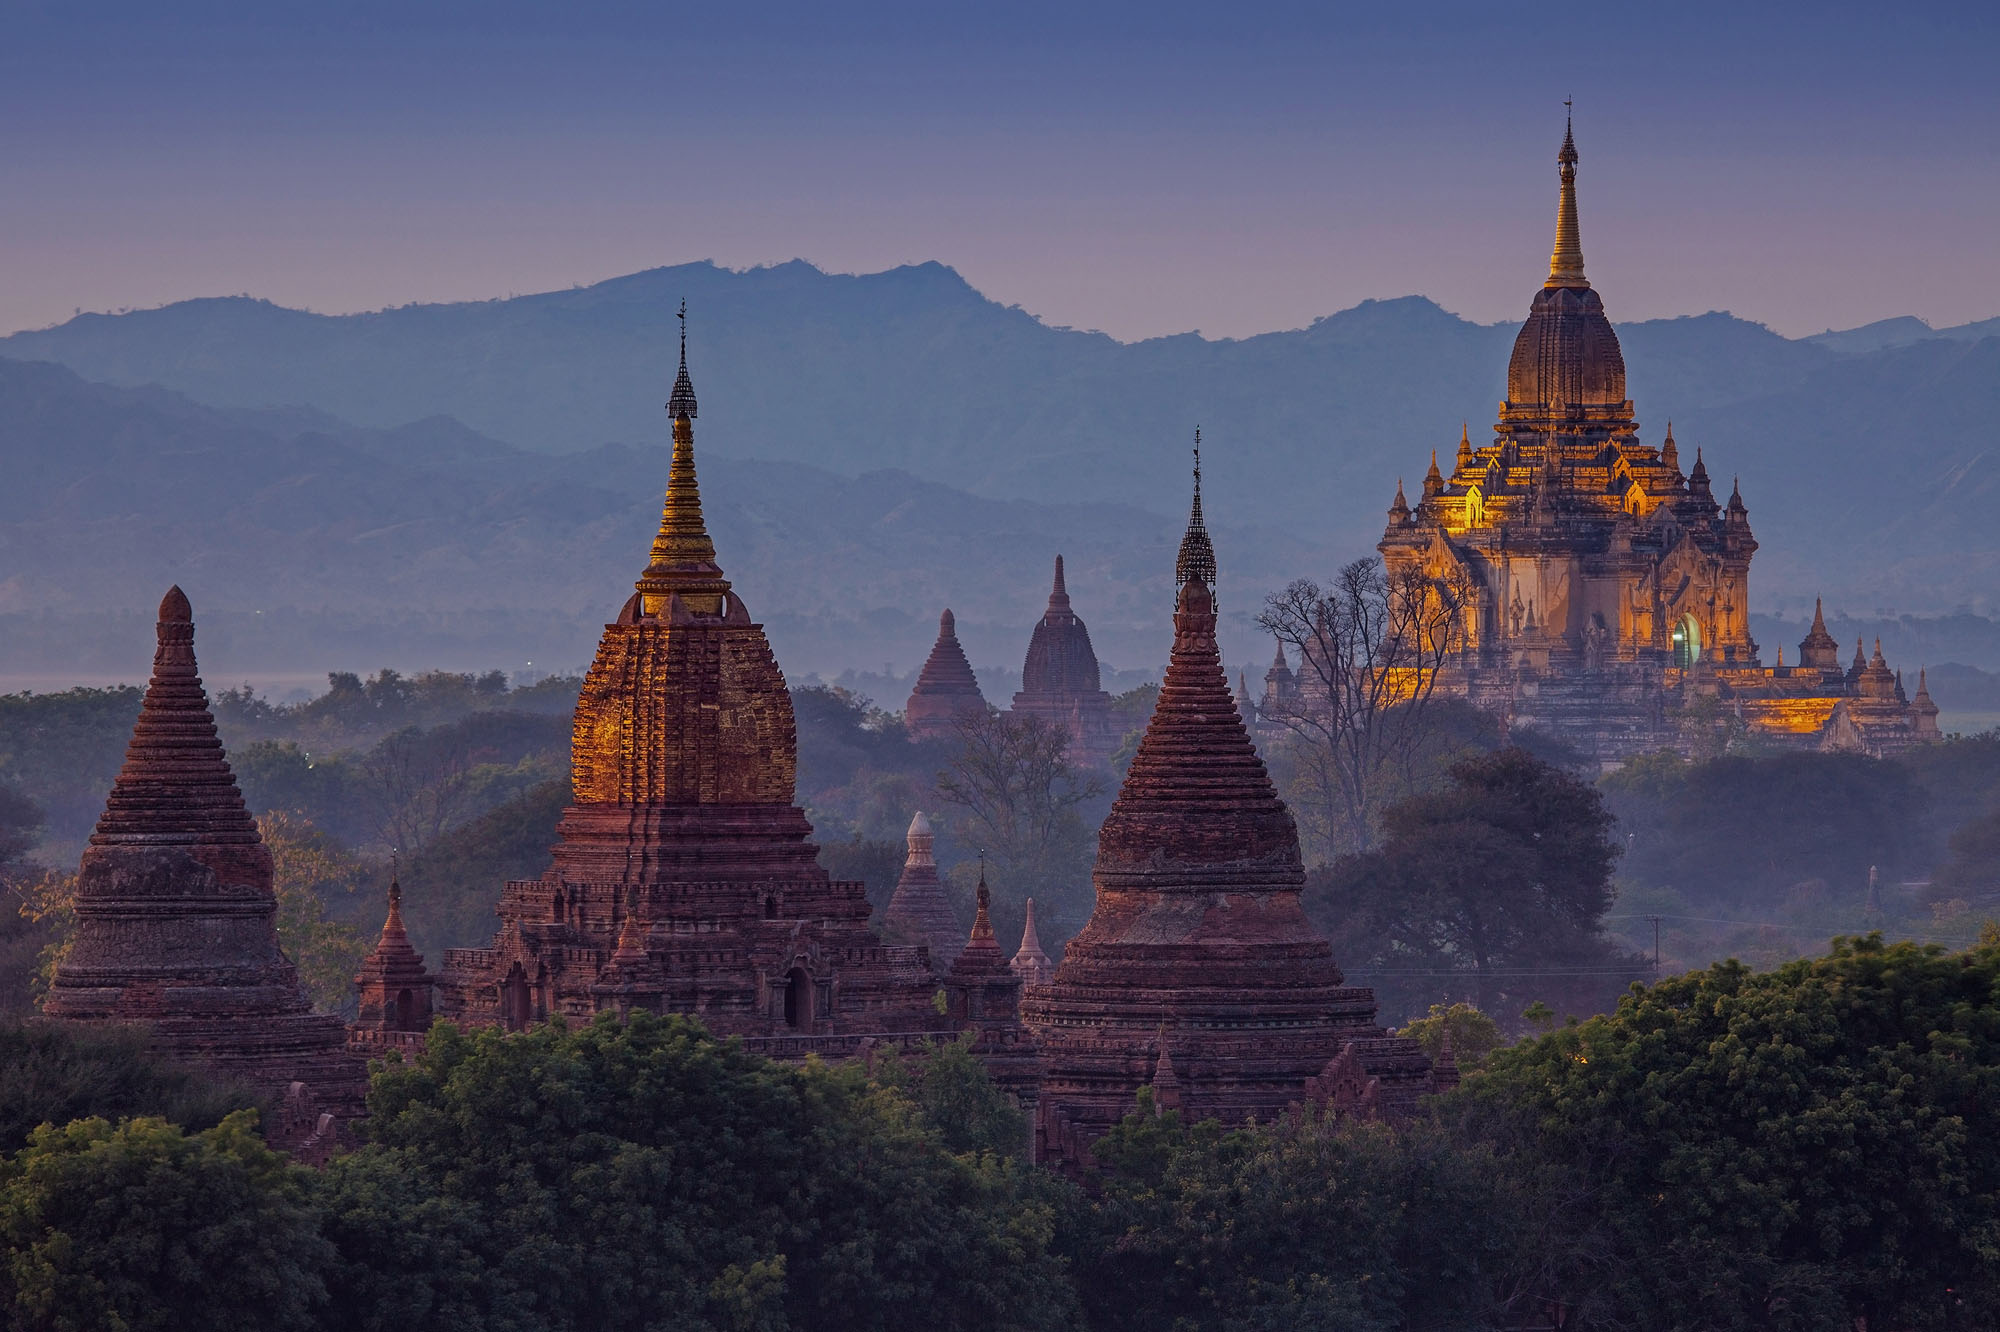What do you think is going on in this snapshot? The image captures an enchanting view of the ancient city of Bagan, Myanmar. The scene is filled with numerous timeless temples and pagodas, their brick-red structures standing gracefully against a mountainous backdrop. Ornate golden spires crown many of these edifices, glimmering brilliantly under the soft glow of the setting sun. The panoramic perspective offers a sweeping vista, placing the temples and pagodas prominently in the foreground, while the majestic mountains loom in the distance. The sky, painted in enchanting shades of purple by the descending dusk, adds a mystical allure to the scenery. The sun’s warm light delicately illuminates the temples, accentuating their exquisite architecture and the profound historical and cultural heritage they embody. This snapshot is a serene testament to both the natural beauty and rich history of this storied locale. 